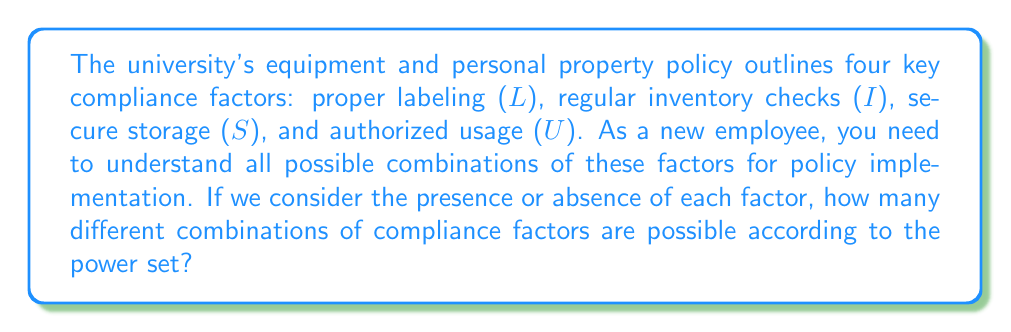Give your solution to this math problem. To solve this problem, we need to apply the concept of power sets to the given compliance factors. Let's break it down step-by-step:

1) First, we identify the set of compliance factors:
   $A = \{L, I, S, U\}$

2) The power set of A, denoted as $P(A)$, is the set of all possible subsets of A, including the empty set and A itself.

3) To calculate the number of elements in the power set, we use the formula:
   $|P(A)| = 2^n$, where $n$ is the number of elements in the original set.

4) In this case, $n = 4$ (since there are 4 compliance factors).

5) Therefore, the number of elements in the power set is:
   $|P(A)| = 2^4 = 16$

6) To verify, we can list all possible combinations:
   $$\begin{align}
   &\{\}, \\
   &\{L\}, \{I\}, \{S\}, \{U\}, \\
   &\{L,I\}, \{L,S\}, \{L,U\}, \{I,S\}, \{I,U\}, \{S,U\}, \\
   &\{L,I,S\}, \{L,I,U\}, \{L,S,U\}, \{I,S,U\}, \\
   &\{L,I,S,U\}
   \end{align}$$

This list indeed contains 16 different combinations, confirming our calculation.
Answer: The number of possible combinations of compliance factors is $2^4 = 16$. 